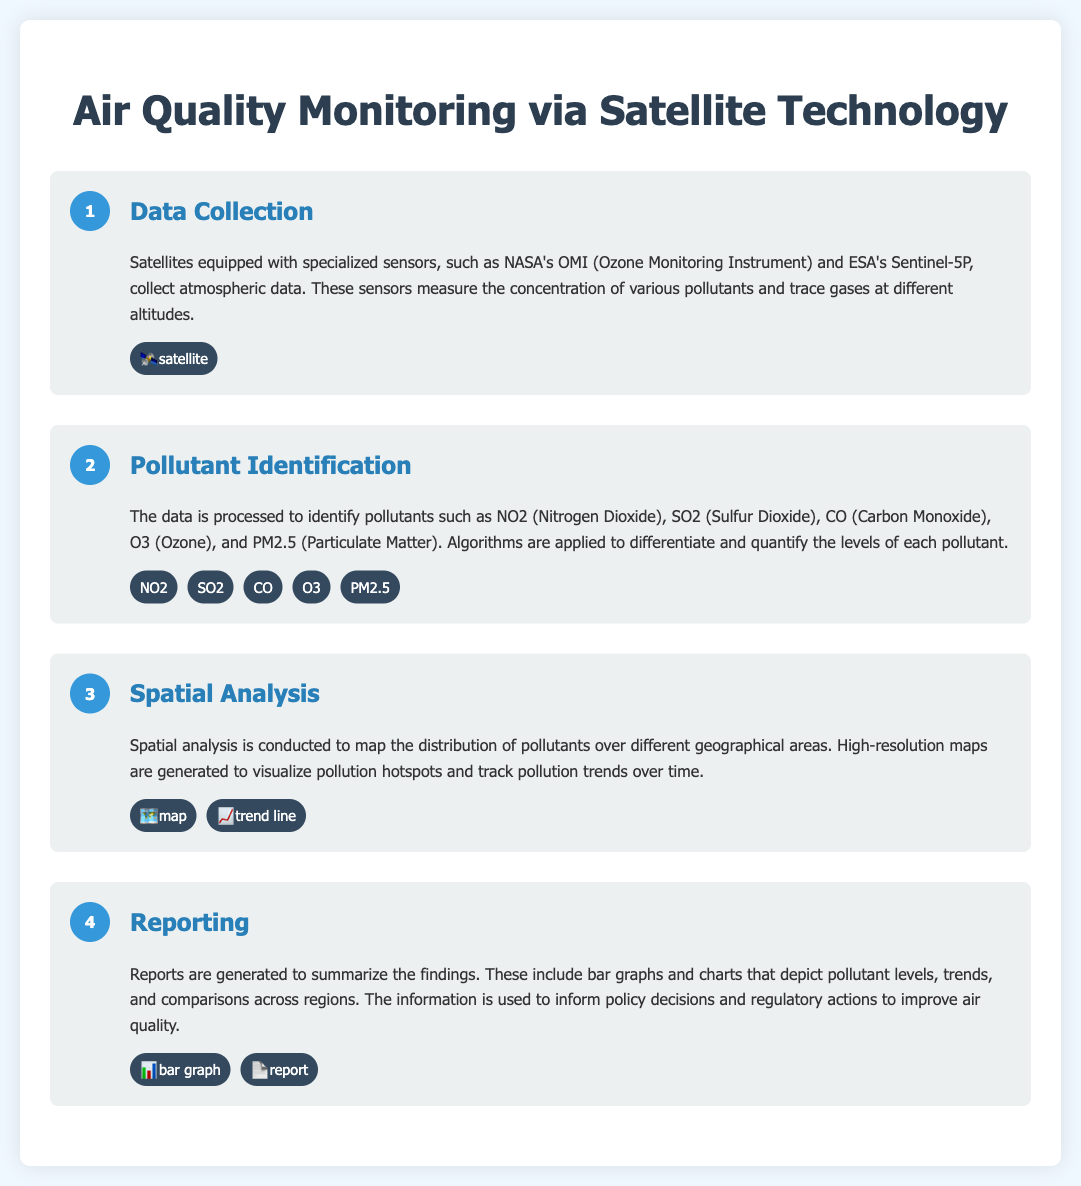What are the names of two satellites mentioned? The document lists NASA's OMI (Ozone Monitoring Instrument) and ESA's Sentinel-5P as the satellites used for data collection.
Answer: OMI, Sentinel-5P What pollutants are identified in the monitoring process? The pollutants mentioned include NO2, SO2, CO, O3, and PM2.5, which are specified in the pollutant identification section.
Answer: NO2, SO2, CO, O3, PM2.5 How many steps are in the air quality monitoring process? There are four steps described in the air quality monitoring process infographic.
Answer: 4 What does the spatial analysis step focus on? The spatial analysis step focuses on mapping the distribution of pollutants and visualizing pollution hotspots, as stated in that section.
Answer: Mapping distribution What visual aids are used in the reporting step? The reporting step mentions the use of bar graphs and charts to depict pollutant levels, trends, and comparisons across regions.
Answer: Bar graphs, charts What type of data do the satellites collect? The satellites collect atmospheric data concerning various pollutants and trace gases at different altitudes.
Answer: Atmospheric data What is the purpose of the generated reports? The reports are generated to summarize the findings and inform policy decisions and regulatory actions to improve air quality.
Answer: Inform policy decisions What visual icon represents the data collection step? The data collection step is visually represented by a satellite icon.
Answer: Satellite icon 